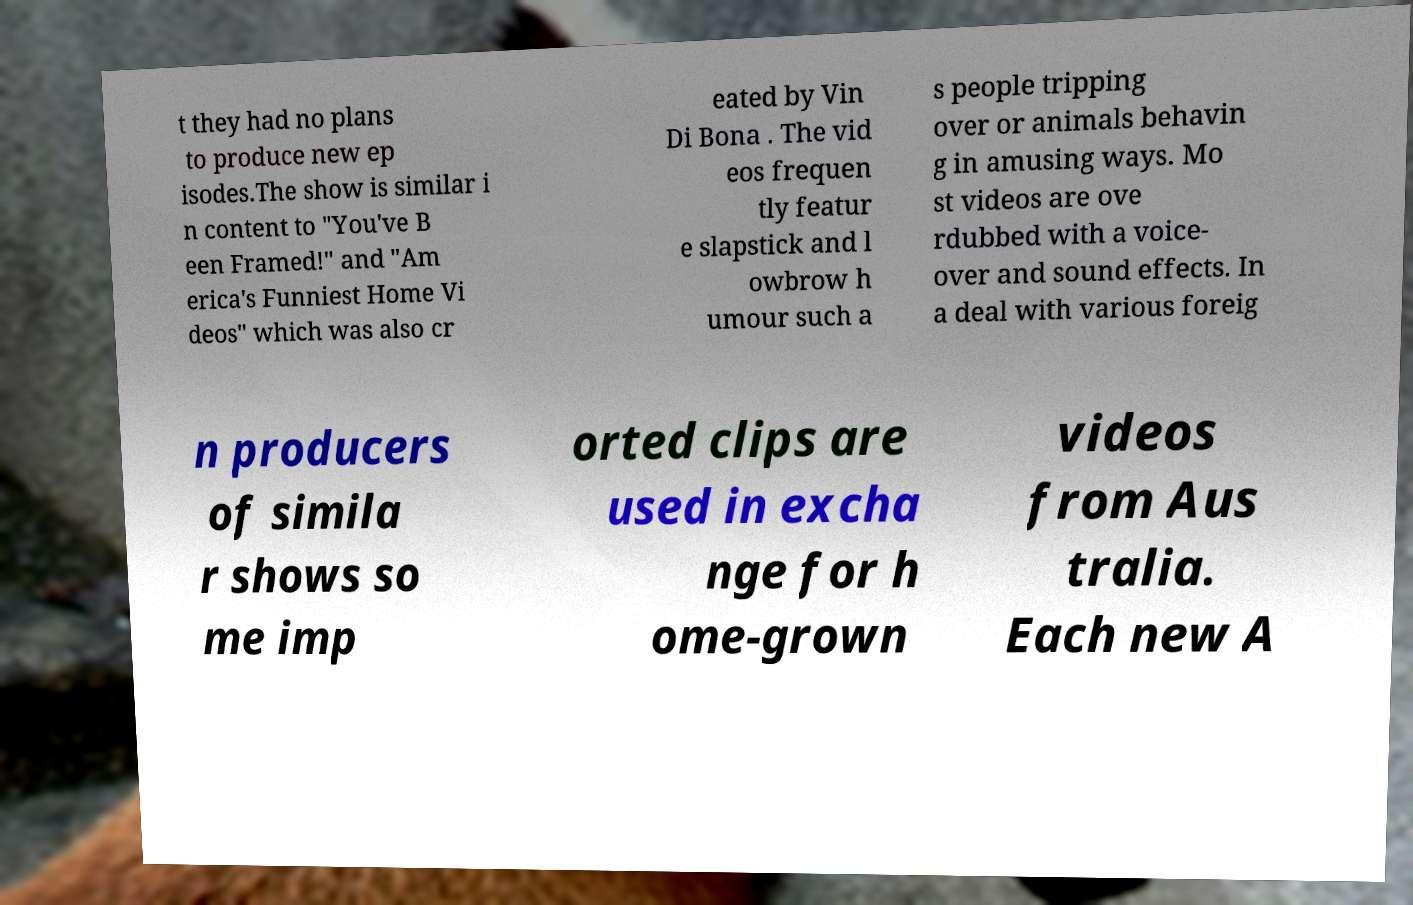Could you extract and type out the text from this image? t they had no plans to produce new ep isodes.The show is similar i n content to "You've B een Framed!" and "Am erica's Funniest Home Vi deos" which was also cr eated by Vin Di Bona . The vid eos frequen tly featur e slapstick and l owbrow h umour such a s people tripping over or animals behavin g in amusing ways. Mo st videos are ove rdubbed with a voice- over and sound effects. In a deal with various foreig n producers of simila r shows so me imp orted clips are used in excha nge for h ome-grown videos from Aus tralia. Each new A 